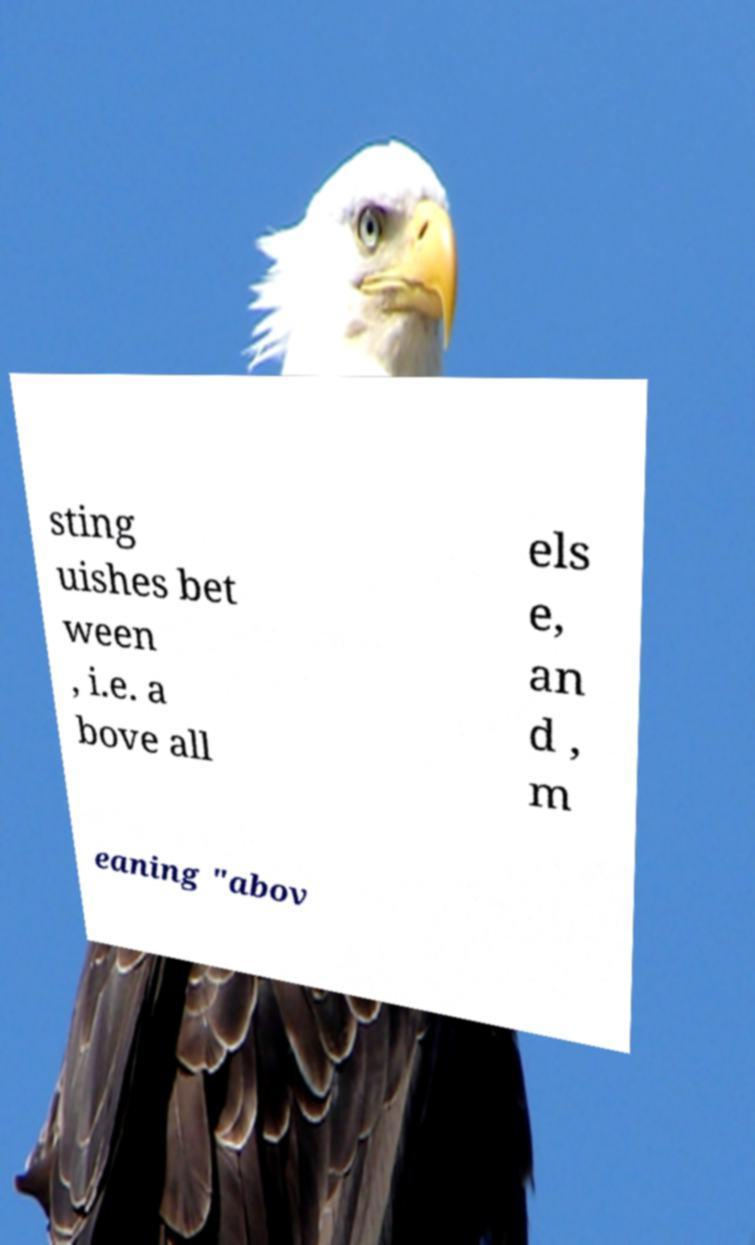I need the written content from this picture converted into text. Can you do that? sting uishes bet ween , i.e. a bove all els e, an d , m eaning "abov 